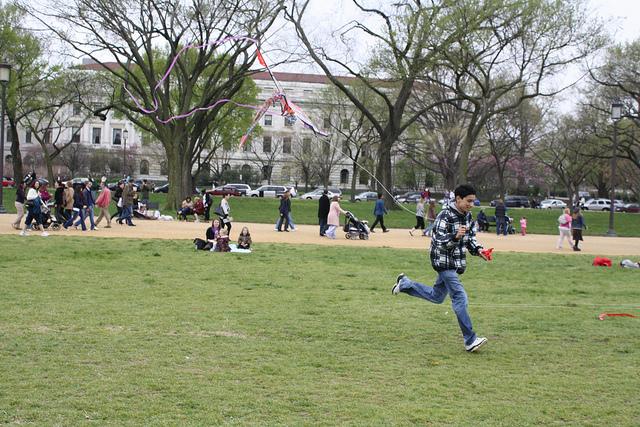What is the man running with?
Give a very brief answer. Kite. What time of day is it?
Concise answer only. Afternoon. What color of pants has the man running worn?
Concise answer only. Blue. What are they getting ready to do?
Answer briefly. Fly kite. 